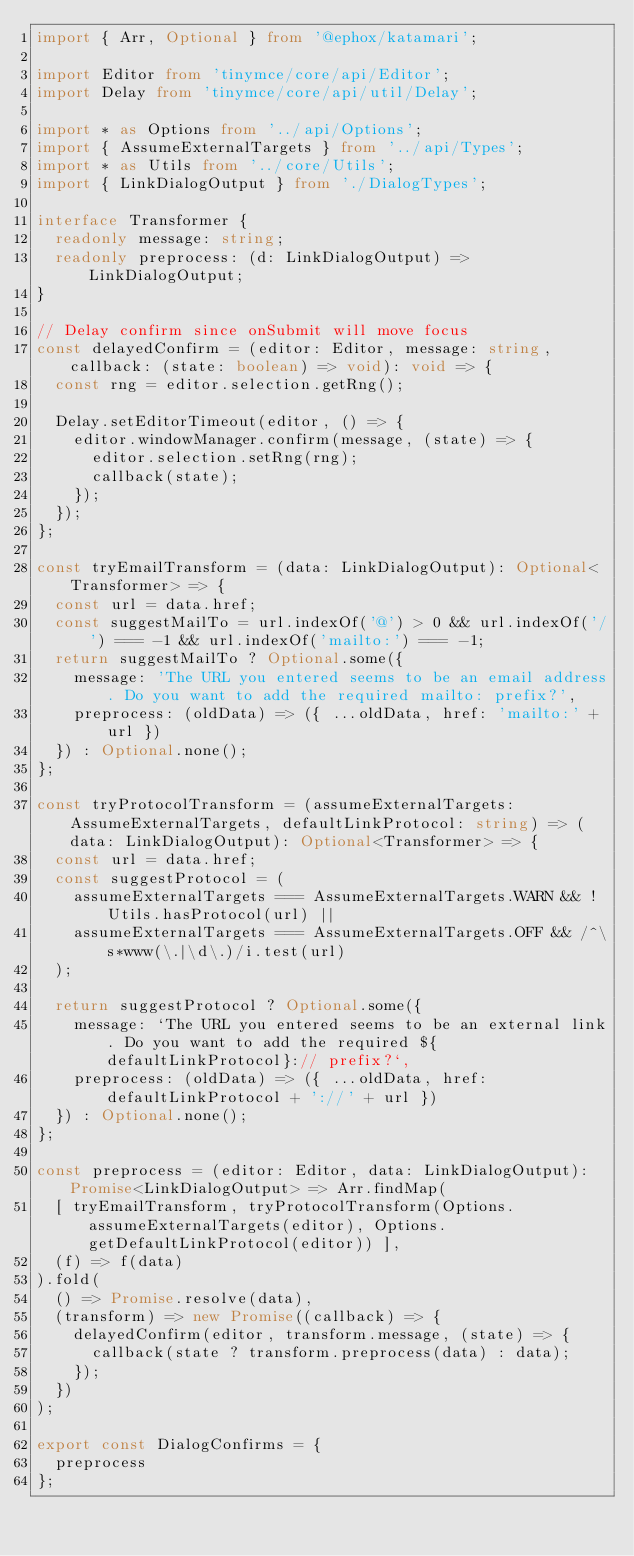Convert code to text. <code><loc_0><loc_0><loc_500><loc_500><_TypeScript_>import { Arr, Optional } from '@ephox/katamari';

import Editor from 'tinymce/core/api/Editor';
import Delay from 'tinymce/core/api/util/Delay';

import * as Options from '../api/Options';
import { AssumeExternalTargets } from '../api/Types';
import * as Utils from '../core/Utils';
import { LinkDialogOutput } from './DialogTypes';

interface Transformer {
  readonly message: string;
  readonly preprocess: (d: LinkDialogOutput) => LinkDialogOutput;
}

// Delay confirm since onSubmit will move focus
const delayedConfirm = (editor: Editor, message: string, callback: (state: boolean) => void): void => {
  const rng = editor.selection.getRng();

  Delay.setEditorTimeout(editor, () => {
    editor.windowManager.confirm(message, (state) => {
      editor.selection.setRng(rng);
      callback(state);
    });
  });
};

const tryEmailTransform = (data: LinkDialogOutput): Optional<Transformer> => {
  const url = data.href;
  const suggestMailTo = url.indexOf('@') > 0 && url.indexOf('/') === -1 && url.indexOf('mailto:') === -1;
  return suggestMailTo ? Optional.some({
    message: 'The URL you entered seems to be an email address. Do you want to add the required mailto: prefix?',
    preprocess: (oldData) => ({ ...oldData, href: 'mailto:' + url })
  }) : Optional.none();
};

const tryProtocolTransform = (assumeExternalTargets: AssumeExternalTargets, defaultLinkProtocol: string) => (data: LinkDialogOutput): Optional<Transformer> => {
  const url = data.href;
  const suggestProtocol = (
    assumeExternalTargets === AssumeExternalTargets.WARN && !Utils.hasProtocol(url) ||
    assumeExternalTargets === AssumeExternalTargets.OFF && /^\s*www(\.|\d\.)/i.test(url)
  );

  return suggestProtocol ? Optional.some({
    message: `The URL you entered seems to be an external link. Do you want to add the required ${defaultLinkProtocol}:// prefix?`,
    preprocess: (oldData) => ({ ...oldData, href: defaultLinkProtocol + '://' + url })
  }) : Optional.none();
};

const preprocess = (editor: Editor, data: LinkDialogOutput): Promise<LinkDialogOutput> => Arr.findMap(
  [ tryEmailTransform, tryProtocolTransform(Options.assumeExternalTargets(editor), Options.getDefaultLinkProtocol(editor)) ],
  (f) => f(data)
).fold(
  () => Promise.resolve(data),
  (transform) => new Promise((callback) => {
    delayedConfirm(editor, transform.message, (state) => {
      callback(state ? transform.preprocess(data) : data);
    });
  })
);

export const DialogConfirms = {
  preprocess
};
</code> 